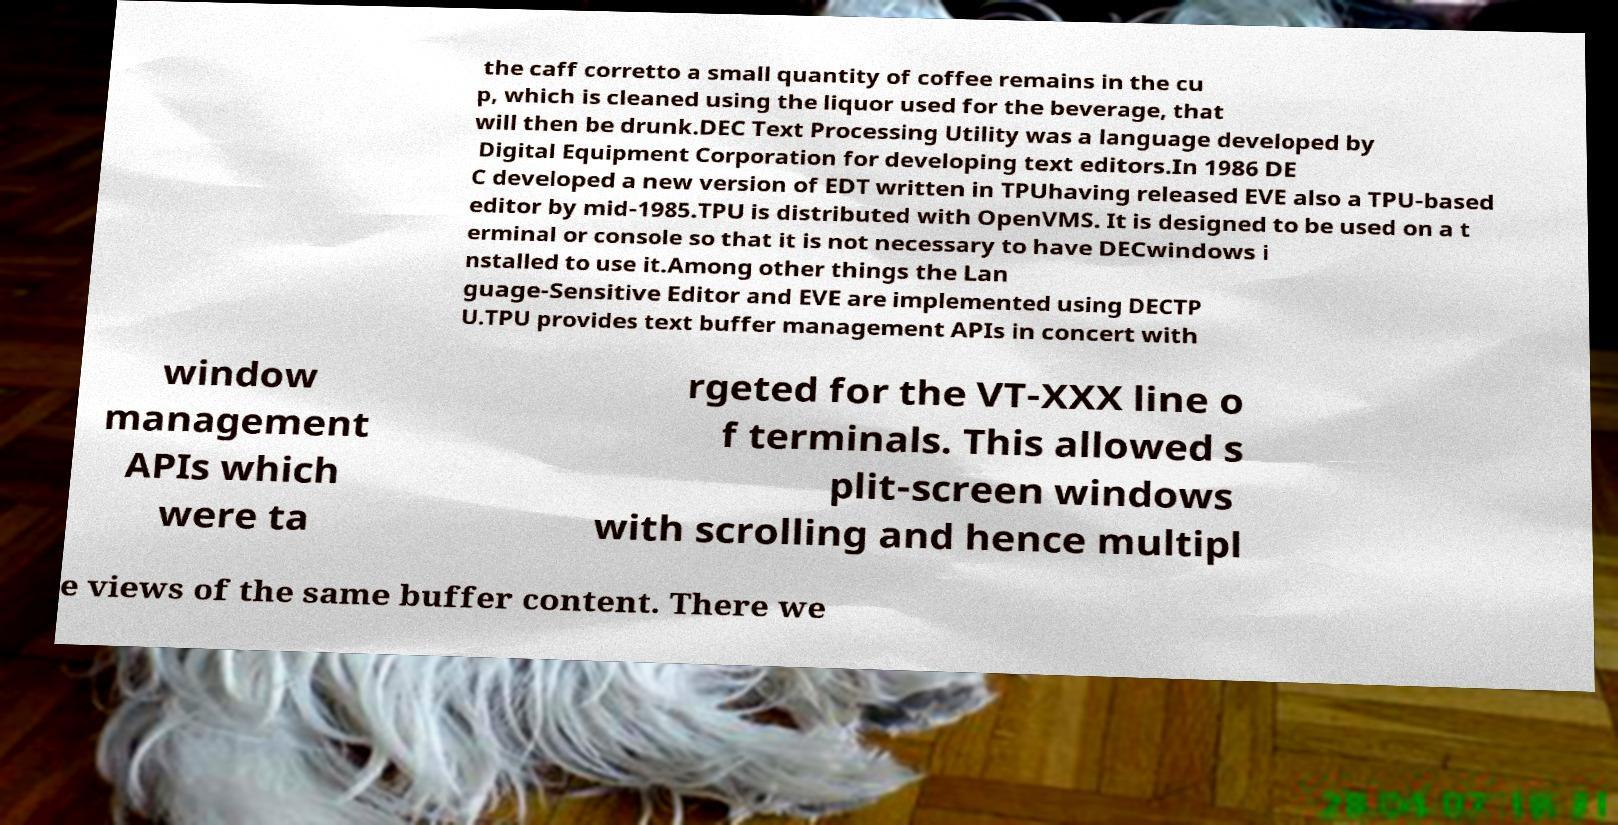There's text embedded in this image that I need extracted. Can you transcribe it verbatim? the caff corretto a small quantity of coffee remains in the cu p, which is cleaned using the liquor used for the beverage, that will then be drunk.DEC Text Processing Utility was a language developed by Digital Equipment Corporation for developing text editors.In 1986 DE C developed a new version of EDT written in TPUhaving released EVE also a TPU-based editor by mid-1985.TPU is distributed with OpenVMS. It is designed to be used on a t erminal or console so that it is not necessary to have DECwindows i nstalled to use it.Among other things the Lan guage-Sensitive Editor and EVE are implemented using DECTP U.TPU provides text buffer management APIs in concert with window management APIs which were ta rgeted for the VT-XXX line o f terminals. This allowed s plit-screen windows with scrolling and hence multipl e views of the same buffer content. There we 